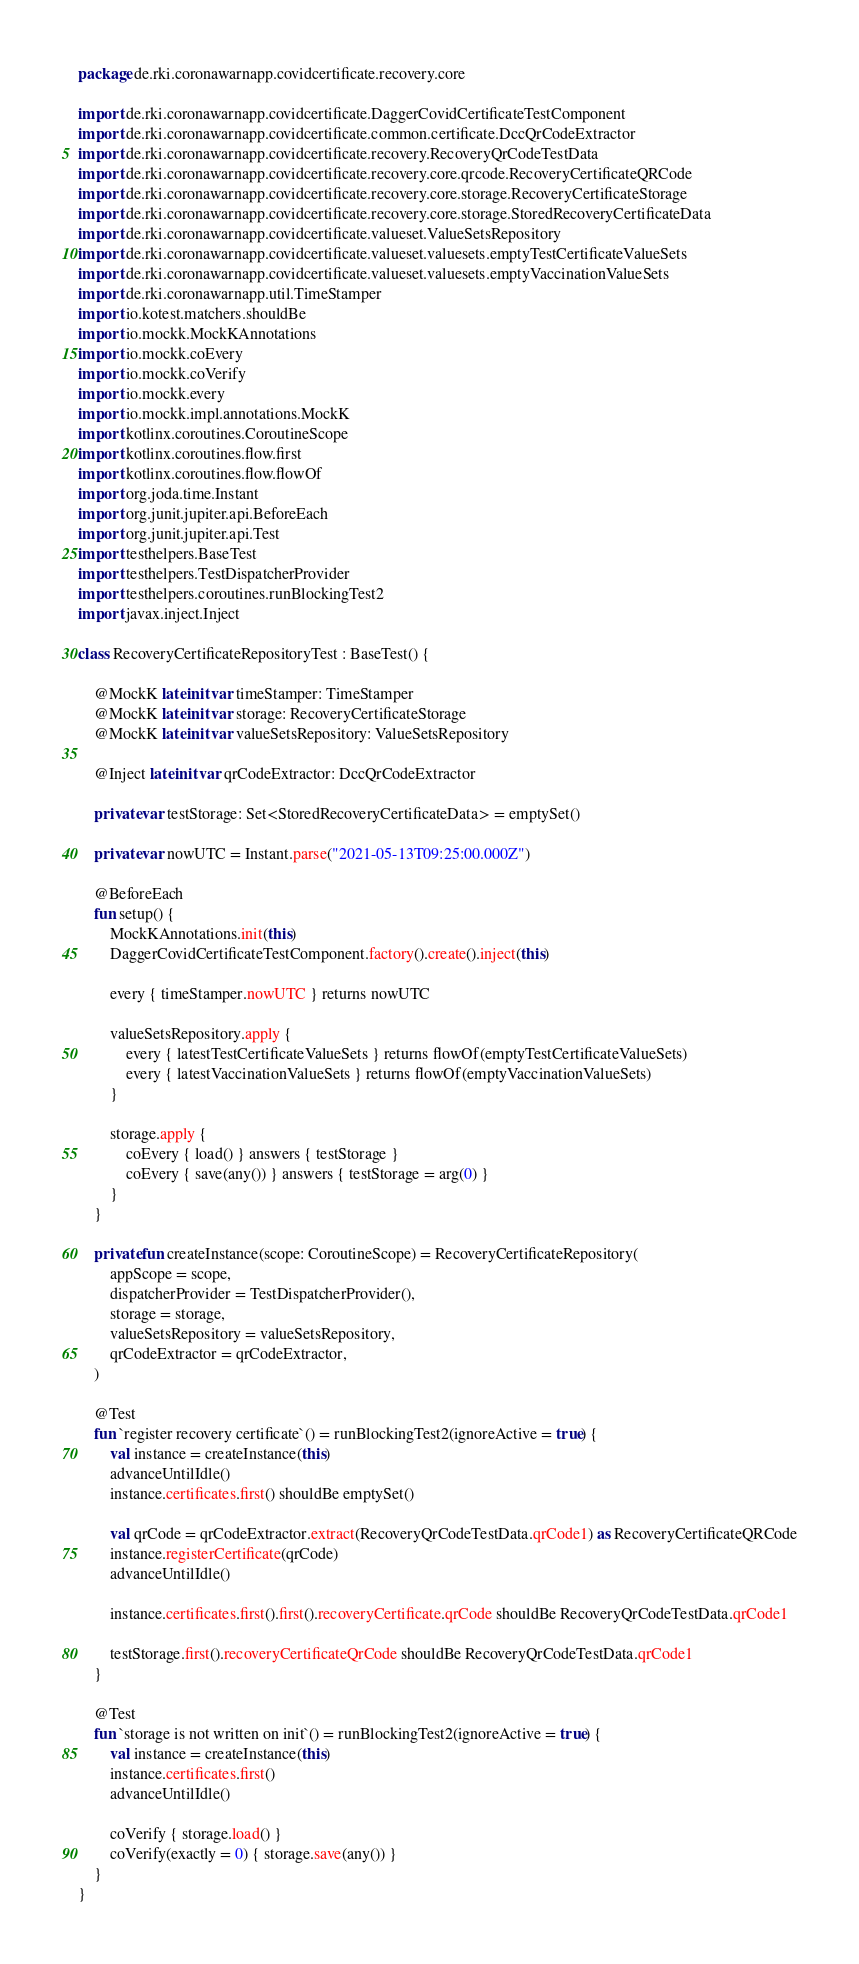<code> <loc_0><loc_0><loc_500><loc_500><_Kotlin_>package de.rki.coronawarnapp.covidcertificate.recovery.core

import de.rki.coronawarnapp.covidcertificate.DaggerCovidCertificateTestComponent
import de.rki.coronawarnapp.covidcertificate.common.certificate.DccQrCodeExtractor
import de.rki.coronawarnapp.covidcertificate.recovery.RecoveryQrCodeTestData
import de.rki.coronawarnapp.covidcertificate.recovery.core.qrcode.RecoveryCertificateQRCode
import de.rki.coronawarnapp.covidcertificate.recovery.core.storage.RecoveryCertificateStorage
import de.rki.coronawarnapp.covidcertificate.recovery.core.storage.StoredRecoveryCertificateData
import de.rki.coronawarnapp.covidcertificate.valueset.ValueSetsRepository
import de.rki.coronawarnapp.covidcertificate.valueset.valuesets.emptyTestCertificateValueSets
import de.rki.coronawarnapp.covidcertificate.valueset.valuesets.emptyVaccinationValueSets
import de.rki.coronawarnapp.util.TimeStamper
import io.kotest.matchers.shouldBe
import io.mockk.MockKAnnotations
import io.mockk.coEvery
import io.mockk.coVerify
import io.mockk.every
import io.mockk.impl.annotations.MockK
import kotlinx.coroutines.CoroutineScope
import kotlinx.coroutines.flow.first
import kotlinx.coroutines.flow.flowOf
import org.joda.time.Instant
import org.junit.jupiter.api.BeforeEach
import org.junit.jupiter.api.Test
import testhelpers.BaseTest
import testhelpers.TestDispatcherProvider
import testhelpers.coroutines.runBlockingTest2
import javax.inject.Inject

class RecoveryCertificateRepositoryTest : BaseTest() {

    @MockK lateinit var timeStamper: TimeStamper
    @MockK lateinit var storage: RecoveryCertificateStorage
    @MockK lateinit var valueSetsRepository: ValueSetsRepository

    @Inject lateinit var qrCodeExtractor: DccQrCodeExtractor

    private var testStorage: Set<StoredRecoveryCertificateData> = emptySet()

    private var nowUTC = Instant.parse("2021-05-13T09:25:00.000Z")

    @BeforeEach
    fun setup() {
        MockKAnnotations.init(this)
        DaggerCovidCertificateTestComponent.factory().create().inject(this)

        every { timeStamper.nowUTC } returns nowUTC

        valueSetsRepository.apply {
            every { latestTestCertificateValueSets } returns flowOf(emptyTestCertificateValueSets)
            every { latestVaccinationValueSets } returns flowOf(emptyVaccinationValueSets)
        }

        storage.apply {
            coEvery { load() } answers { testStorage }
            coEvery { save(any()) } answers { testStorage = arg(0) }
        }
    }

    private fun createInstance(scope: CoroutineScope) = RecoveryCertificateRepository(
        appScope = scope,
        dispatcherProvider = TestDispatcherProvider(),
        storage = storage,
        valueSetsRepository = valueSetsRepository,
        qrCodeExtractor = qrCodeExtractor,
    )

    @Test
    fun `register recovery certificate`() = runBlockingTest2(ignoreActive = true) {
        val instance = createInstance(this)
        advanceUntilIdle()
        instance.certificates.first() shouldBe emptySet()

        val qrCode = qrCodeExtractor.extract(RecoveryQrCodeTestData.qrCode1) as RecoveryCertificateQRCode
        instance.registerCertificate(qrCode)
        advanceUntilIdle()

        instance.certificates.first().first().recoveryCertificate.qrCode shouldBe RecoveryQrCodeTestData.qrCode1

        testStorage.first().recoveryCertificateQrCode shouldBe RecoveryQrCodeTestData.qrCode1
    }

    @Test
    fun `storage is not written on init`() = runBlockingTest2(ignoreActive = true) {
        val instance = createInstance(this)
        instance.certificates.first()
        advanceUntilIdle()

        coVerify { storage.load() }
        coVerify(exactly = 0) { storage.save(any()) }
    }
}
</code> 